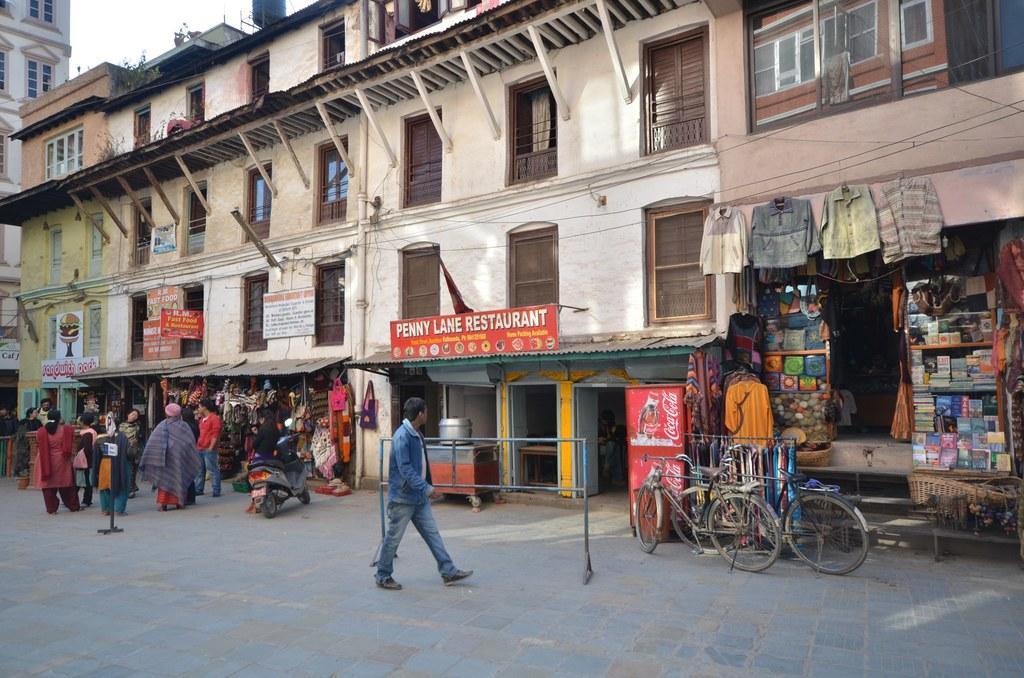Describe this image in one or two sentences. In this image we can see some people on the street and to the side we can see some stores with clothes and some other objects, vehicles on the road. We can also see few buildings and there are some boards attached to the buildings with some text. 